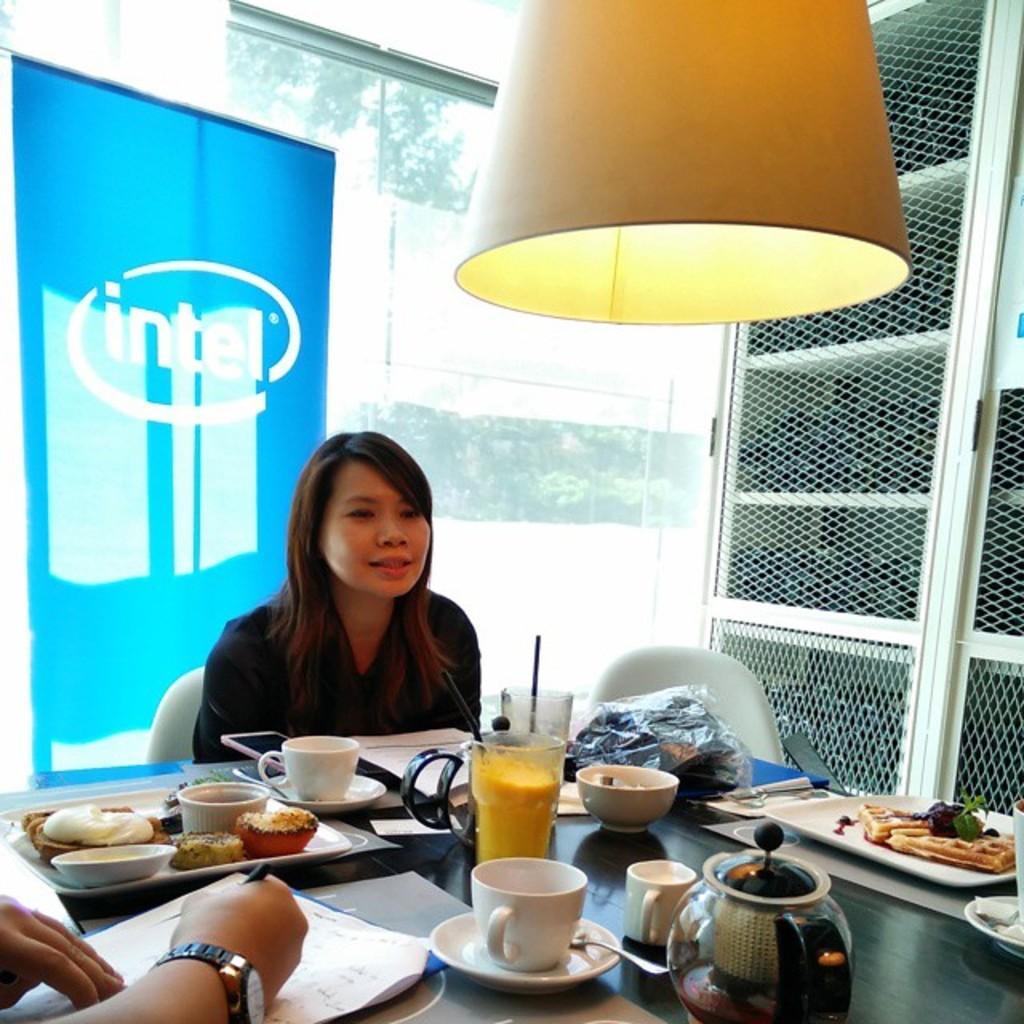How would you summarize this image in a sentence or two? On the table there is cup,drink,glass,bowl,saucer,tray,food,above the table there is light,woman sitting on the chair,in the background there is glass,another person sitting wearing watch and holding pen. 